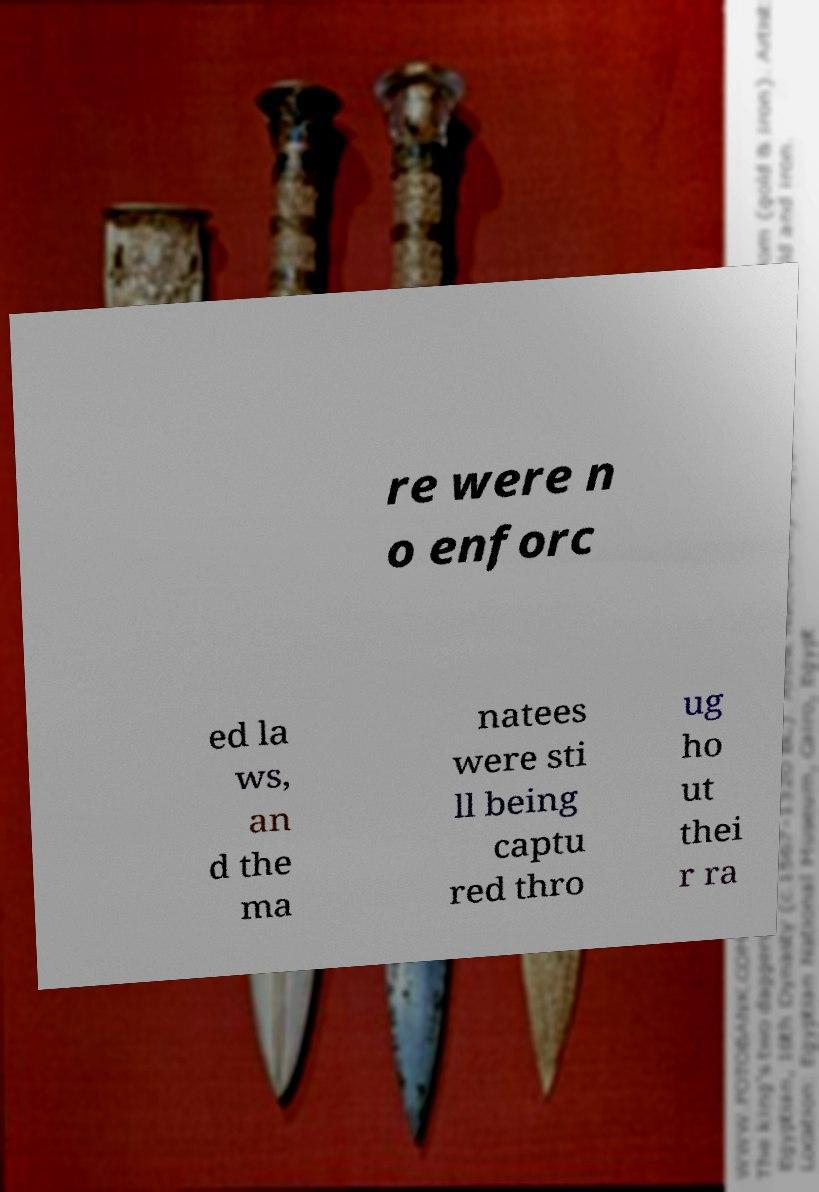Can you read and provide the text displayed in the image?This photo seems to have some interesting text. Can you extract and type it out for me? re were n o enforc ed la ws, an d the ma natees were sti ll being captu red thro ug ho ut thei r ra 